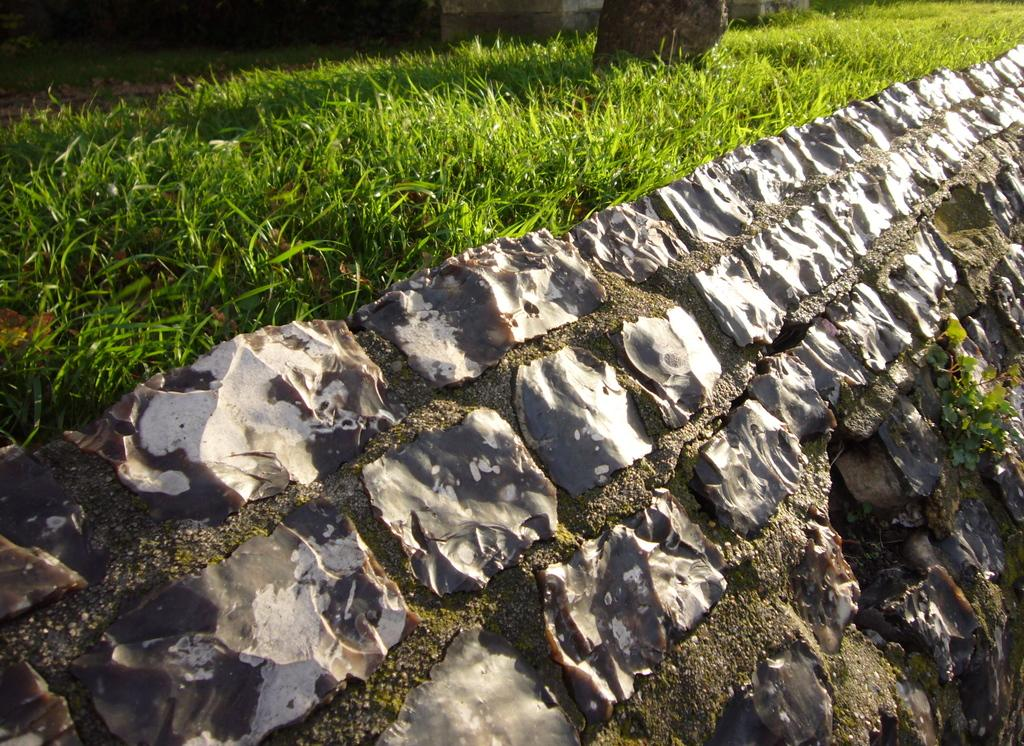What type of vegetation is present in the image? There is grass in the image. What else can be seen in the image besides the grass? There are other objects in the image. Can you describe the plant located at the bottom of the image? The plant looks like stones on a surface. What date is marked on the calendar in the image? There is no calendar present in the image. How does the faucet in the image function? There is no faucet present in the image. 